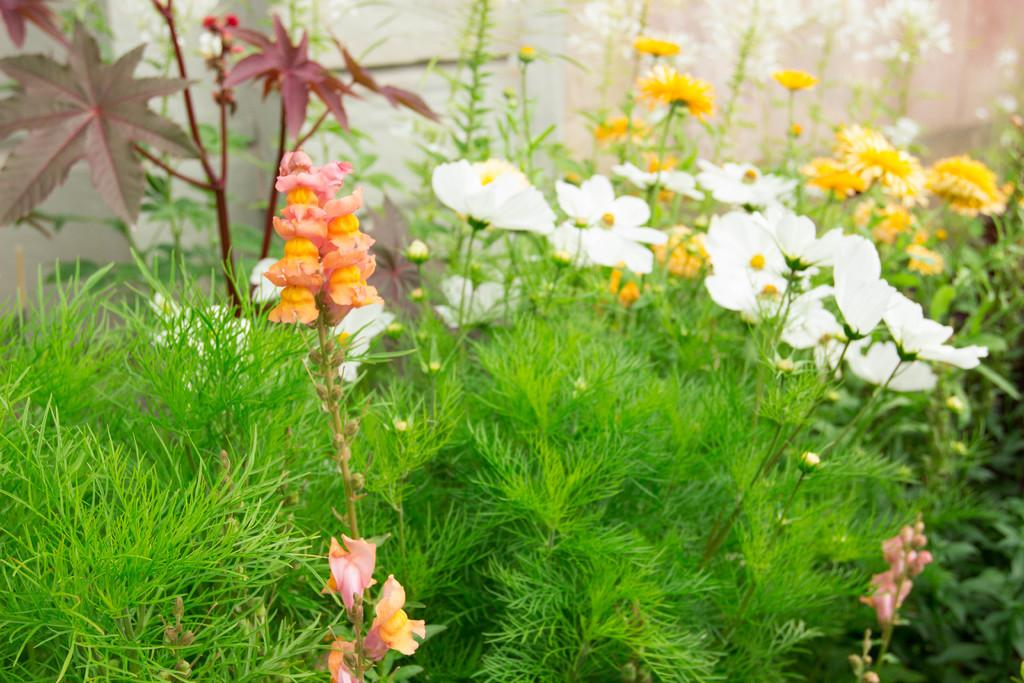What type of plant life can be seen in the image? There are flowers, leaves, stems, and plants visible in the image. Can you describe the structure of the plants in the image? The plants in the image have flowers, leaves, and stems. What is visible in the background of the image? There is a wall visible in the background of the image. What type of glove is being used to water the plants in the image? There is no glove present in the image, and no one is shown watering the plants. 